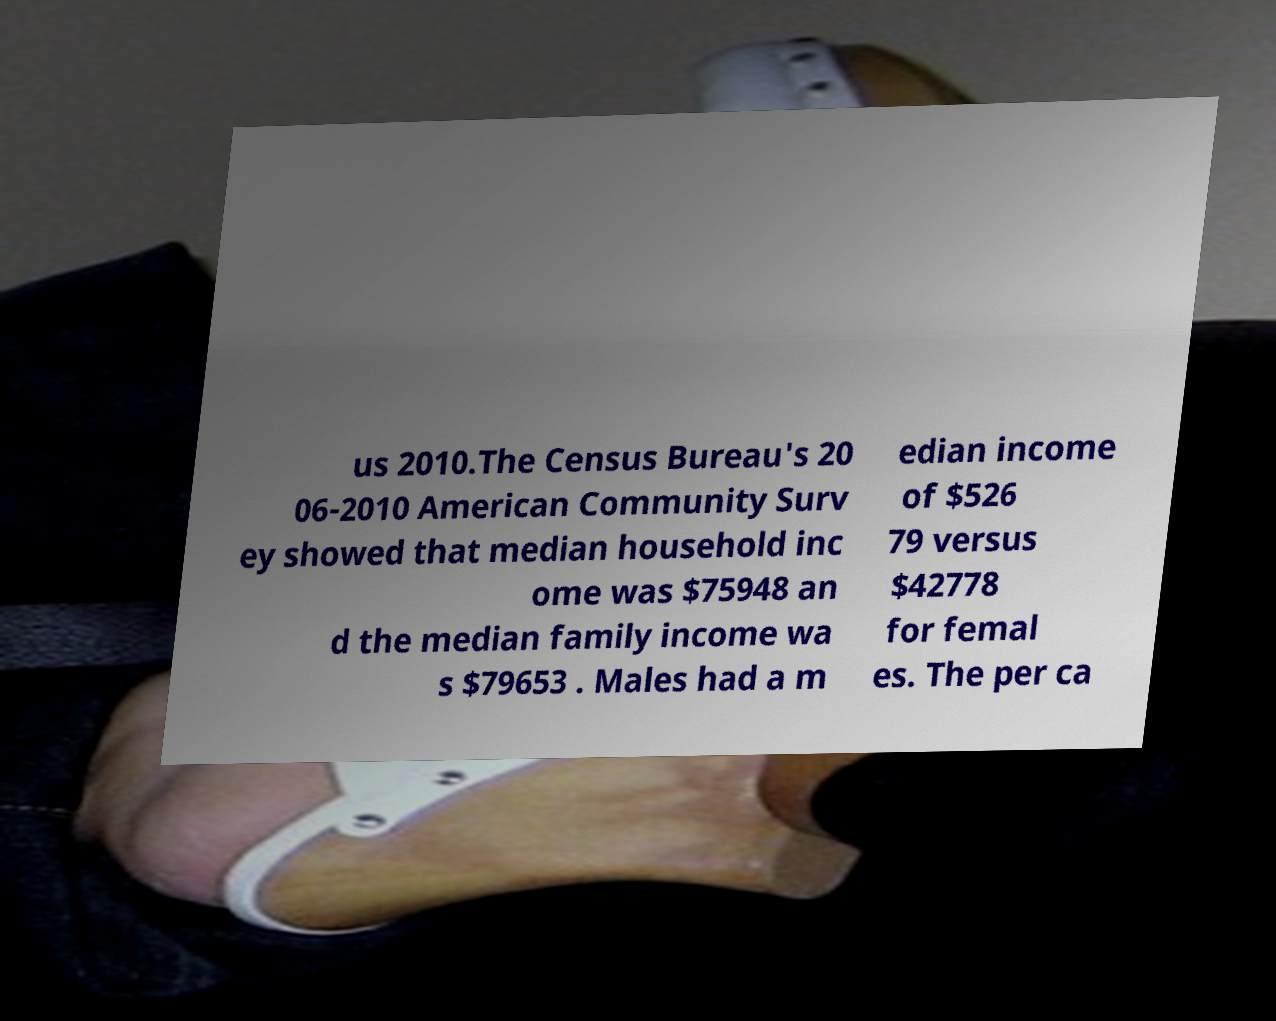I need the written content from this picture converted into text. Can you do that? us 2010.The Census Bureau's 20 06-2010 American Community Surv ey showed that median household inc ome was $75948 an d the median family income wa s $79653 . Males had a m edian income of $526 79 versus $42778 for femal es. The per ca 